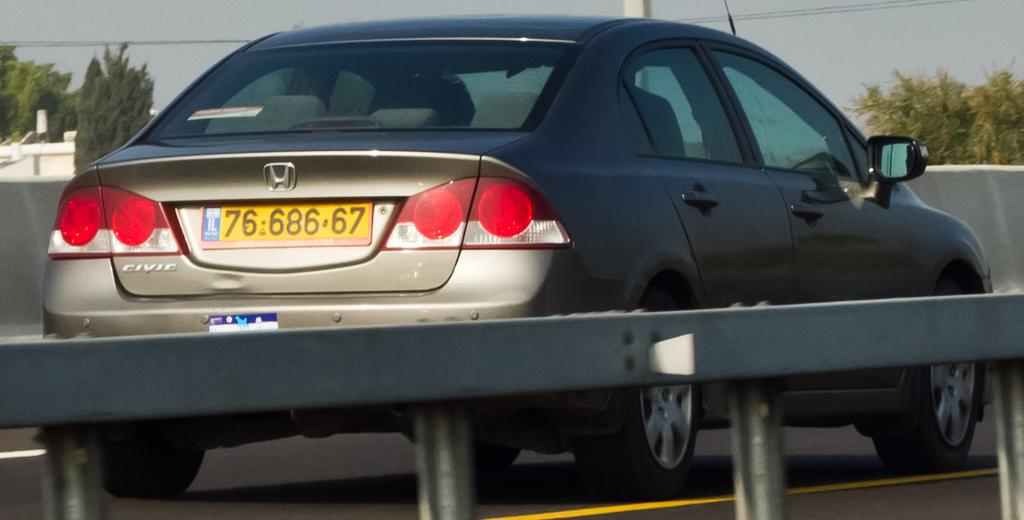<image>
Give a short and clear explanation of the subsequent image. A Honda Civic is driving down the road. 